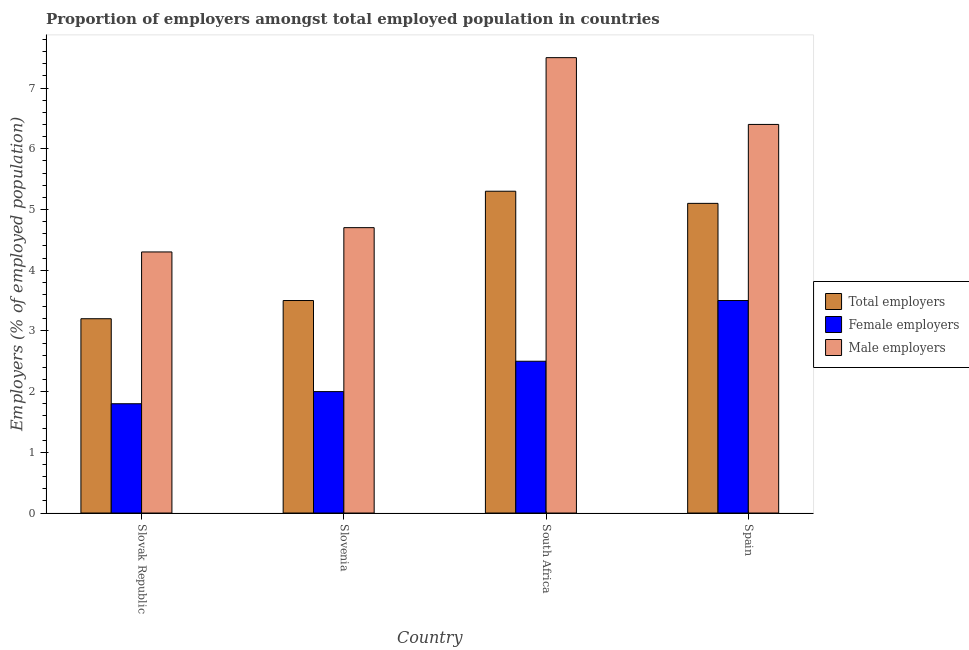What is the label of the 3rd group of bars from the left?
Make the answer very short. South Africa. In how many cases, is the number of bars for a given country not equal to the number of legend labels?
Your response must be concise. 0. Across all countries, what is the minimum percentage of total employers?
Keep it short and to the point. 3.2. In which country was the percentage of total employers maximum?
Provide a short and direct response. South Africa. In which country was the percentage of female employers minimum?
Make the answer very short. Slovak Republic. What is the total percentage of male employers in the graph?
Your response must be concise. 22.9. What is the difference between the percentage of total employers in Slovak Republic and that in South Africa?
Provide a succinct answer. -2.1. What is the difference between the percentage of female employers in Slovak Republic and the percentage of total employers in Spain?
Offer a very short reply. -3.3. What is the average percentage of male employers per country?
Your answer should be compact. 5.73. What is the difference between the percentage of male employers and percentage of female employers in Spain?
Give a very brief answer. 2.9. In how many countries, is the percentage of total employers greater than 1.8 %?
Give a very brief answer. 4. What is the ratio of the percentage of female employers in Slovak Republic to that in Slovenia?
Make the answer very short. 0.9. Is the difference between the percentage of male employers in Slovak Republic and South Africa greater than the difference between the percentage of total employers in Slovak Republic and South Africa?
Your answer should be compact. No. What is the difference between the highest and the second highest percentage of male employers?
Ensure brevity in your answer.  1.1. What is the difference between the highest and the lowest percentage of female employers?
Your response must be concise. 1.7. In how many countries, is the percentage of female employers greater than the average percentage of female employers taken over all countries?
Offer a terse response. 2. Is the sum of the percentage of female employers in Slovak Republic and South Africa greater than the maximum percentage of male employers across all countries?
Ensure brevity in your answer.  No. What does the 3rd bar from the left in Spain represents?
Provide a short and direct response. Male employers. What does the 3rd bar from the right in Spain represents?
Your answer should be very brief. Total employers. Is it the case that in every country, the sum of the percentage of total employers and percentage of female employers is greater than the percentage of male employers?
Ensure brevity in your answer.  Yes. What is the difference between two consecutive major ticks on the Y-axis?
Give a very brief answer. 1. Are the values on the major ticks of Y-axis written in scientific E-notation?
Your answer should be compact. No. Does the graph contain any zero values?
Make the answer very short. No. Does the graph contain grids?
Provide a succinct answer. No. What is the title of the graph?
Your response must be concise. Proportion of employers amongst total employed population in countries. Does "Transport services" appear as one of the legend labels in the graph?
Make the answer very short. No. What is the label or title of the X-axis?
Offer a terse response. Country. What is the label or title of the Y-axis?
Your answer should be very brief. Employers (% of employed population). What is the Employers (% of employed population) of Total employers in Slovak Republic?
Provide a short and direct response. 3.2. What is the Employers (% of employed population) of Female employers in Slovak Republic?
Make the answer very short. 1.8. What is the Employers (% of employed population) in Male employers in Slovak Republic?
Your response must be concise. 4.3. What is the Employers (% of employed population) of Total employers in Slovenia?
Offer a terse response. 3.5. What is the Employers (% of employed population) of Female employers in Slovenia?
Your answer should be very brief. 2. What is the Employers (% of employed population) of Male employers in Slovenia?
Give a very brief answer. 4.7. What is the Employers (% of employed population) in Total employers in South Africa?
Keep it short and to the point. 5.3. What is the Employers (% of employed population) of Total employers in Spain?
Provide a succinct answer. 5.1. What is the Employers (% of employed population) of Female employers in Spain?
Your answer should be very brief. 3.5. What is the Employers (% of employed population) of Male employers in Spain?
Provide a short and direct response. 6.4. Across all countries, what is the maximum Employers (% of employed population) of Total employers?
Make the answer very short. 5.3. Across all countries, what is the maximum Employers (% of employed population) in Female employers?
Provide a short and direct response. 3.5. Across all countries, what is the minimum Employers (% of employed population) of Total employers?
Your answer should be very brief. 3.2. Across all countries, what is the minimum Employers (% of employed population) of Female employers?
Provide a short and direct response. 1.8. Across all countries, what is the minimum Employers (% of employed population) of Male employers?
Offer a terse response. 4.3. What is the total Employers (% of employed population) in Male employers in the graph?
Provide a succinct answer. 22.9. What is the difference between the Employers (% of employed population) in Female employers in Slovak Republic and that in Slovenia?
Keep it short and to the point. -0.2. What is the difference between the Employers (% of employed population) in Male employers in Slovak Republic and that in Slovenia?
Make the answer very short. -0.4. What is the difference between the Employers (% of employed population) in Female employers in Slovak Republic and that in South Africa?
Your response must be concise. -0.7. What is the difference between the Employers (% of employed population) in Total employers in Slovak Republic and that in Spain?
Provide a succinct answer. -1.9. What is the difference between the Employers (% of employed population) of Female employers in Slovak Republic and that in Spain?
Give a very brief answer. -1.7. What is the difference between the Employers (% of employed population) of Total employers in Slovenia and that in South Africa?
Offer a terse response. -1.8. What is the difference between the Employers (% of employed population) of Male employers in Slovenia and that in South Africa?
Offer a terse response. -2.8. What is the difference between the Employers (% of employed population) in Total employers in Slovenia and that in Spain?
Make the answer very short. -1.6. What is the difference between the Employers (% of employed population) in Male employers in Slovenia and that in Spain?
Your answer should be very brief. -1.7. What is the difference between the Employers (% of employed population) in Female employers in Slovak Republic and the Employers (% of employed population) in Male employers in Slovenia?
Provide a short and direct response. -2.9. What is the difference between the Employers (% of employed population) of Total employers in Slovak Republic and the Employers (% of employed population) of Female employers in South Africa?
Offer a terse response. 0.7. What is the difference between the Employers (% of employed population) in Total employers in Slovak Republic and the Employers (% of employed population) in Male employers in South Africa?
Offer a terse response. -4.3. What is the difference between the Employers (% of employed population) in Female employers in Slovak Republic and the Employers (% of employed population) in Male employers in South Africa?
Offer a very short reply. -5.7. What is the difference between the Employers (% of employed population) in Total employers in Slovak Republic and the Employers (% of employed population) in Male employers in Spain?
Provide a short and direct response. -3.2. What is the difference between the Employers (% of employed population) in Female employers in Slovak Republic and the Employers (% of employed population) in Male employers in Spain?
Your answer should be compact. -4.6. What is the difference between the Employers (% of employed population) in Total employers in Slovenia and the Employers (% of employed population) in Male employers in South Africa?
Provide a succinct answer. -4. What is the difference between the Employers (% of employed population) of Female employers in Slovenia and the Employers (% of employed population) of Male employers in South Africa?
Provide a short and direct response. -5.5. What is the difference between the Employers (% of employed population) of Total employers in Slovenia and the Employers (% of employed population) of Male employers in Spain?
Offer a very short reply. -2.9. What is the difference between the Employers (% of employed population) of Female employers in Slovenia and the Employers (% of employed population) of Male employers in Spain?
Give a very brief answer. -4.4. What is the difference between the Employers (% of employed population) of Total employers in South Africa and the Employers (% of employed population) of Female employers in Spain?
Your response must be concise. 1.8. What is the difference between the Employers (% of employed population) of Female employers in South Africa and the Employers (% of employed population) of Male employers in Spain?
Offer a very short reply. -3.9. What is the average Employers (% of employed population) of Total employers per country?
Offer a terse response. 4.28. What is the average Employers (% of employed population) of Female employers per country?
Ensure brevity in your answer.  2.45. What is the average Employers (% of employed population) in Male employers per country?
Offer a very short reply. 5.72. What is the difference between the Employers (% of employed population) of Total employers and Employers (% of employed population) of Male employers in Slovak Republic?
Offer a very short reply. -1.1. What is the difference between the Employers (% of employed population) in Total employers and Employers (% of employed population) in Female employers in Slovenia?
Your response must be concise. 1.5. What is the difference between the Employers (% of employed population) in Female employers and Employers (% of employed population) in Male employers in Slovenia?
Keep it short and to the point. -2.7. What is the difference between the Employers (% of employed population) in Total employers and Employers (% of employed population) in Female employers in South Africa?
Provide a succinct answer. 2.8. What is the difference between the Employers (% of employed population) of Female employers and Employers (% of employed population) of Male employers in South Africa?
Provide a short and direct response. -5. What is the difference between the Employers (% of employed population) of Total employers and Employers (% of employed population) of Female employers in Spain?
Provide a succinct answer. 1.6. What is the difference between the Employers (% of employed population) of Total employers and Employers (% of employed population) of Male employers in Spain?
Offer a very short reply. -1.3. What is the ratio of the Employers (% of employed population) in Total employers in Slovak Republic to that in Slovenia?
Your answer should be very brief. 0.91. What is the ratio of the Employers (% of employed population) of Female employers in Slovak Republic to that in Slovenia?
Offer a very short reply. 0.9. What is the ratio of the Employers (% of employed population) of Male employers in Slovak Republic to that in Slovenia?
Your answer should be very brief. 0.91. What is the ratio of the Employers (% of employed population) of Total employers in Slovak Republic to that in South Africa?
Offer a terse response. 0.6. What is the ratio of the Employers (% of employed population) in Female employers in Slovak Republic to that in South Africa?
Your response must be concise. 0.72. What is the ratio of the Employers (% of employed population) in Male employers in Slovak Republic to that in South Africa?
Make the answer very short. 0.57. What is the ratio of the Employers (% of employed population) in Total employers in Slovak Republic to that in Spain?
Your answer should be compact. 0.63. What is the ratio of the Employers (% of employed population) in Female employers in Slovak Republic to that in Spain?
Your answer should be very brief. 0.51. What is the ratio of the Employers (% of employed population) in Male employers in Slovak Republic to that in Spain?
Your answer should be very brief. 0.67. What is the ratio of the Employers (% of employed population) in Total employers in Slovenia to that in South Africa?
Keep it short and to the point. 0.66. What is the ratio of the Employers (% of employed population) in Male employers in Slovenia to that in South Africa?
Provide a succinct answer. 0.63. What is the ratio of the Employers (% of employed population) of Total employers in Slovenia to that in Spain?
Offer a very short reply. 0.69. What is the ratio of the Employers (% of employed population) in Male employers in Slovenia to that in Spain?
Offer a terse response. 0.73. What is the ratio of the Employers (% of employed population) in Total employers in South Africa to that in Spain?
Your answer should be compact. 1.04. What is the ratio of the Employers (% of employed population) in Male employers in South Africa to that in Spain?
Provide a short and direct response. 1.17. What is the difference between the highest and the second highest Employers (% of employed population) of Male employers?
Make the answer very short. 1.1. 